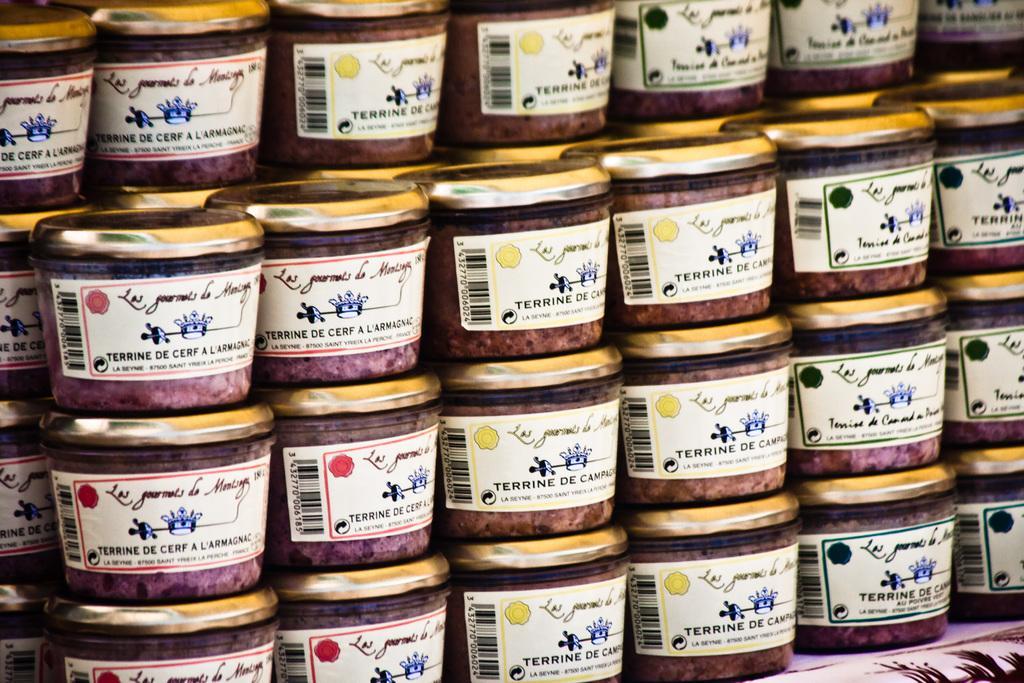In one or two sentences, can you explain what this image depicts? In this image we can see containers are arranged. 